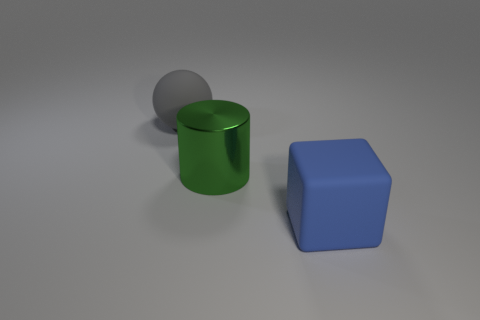Add 3 green things. How many objects exist? 6 Subtract all cylinders. How many objects are left? 2 Subtract 0 purple cylinders. How many objects are left? 3 Subtract all tiny yellow blocks. Subtract all large rubber spheres. How many objects are left? 2 Add 3 green metal cylinders. How many green metal cylinders are left? 4 Add 3 brown matte objects. How many brown matte objects exist? 3 